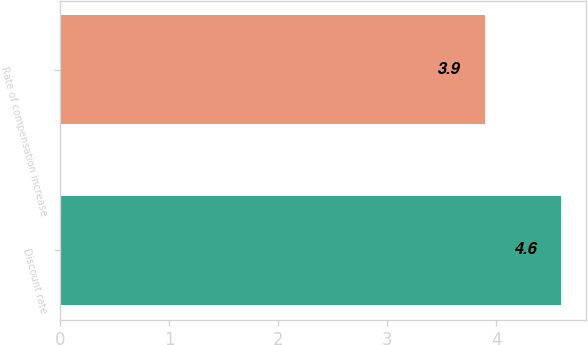Convert chart to OTSL. <chart><loc_0><loc_0><loc_500><loc_500><bar_chart><fcel>Discount rate<fcel>Rate of compensation increase<nl><fcel>4.6<fcel>3.9<nl></chart> 